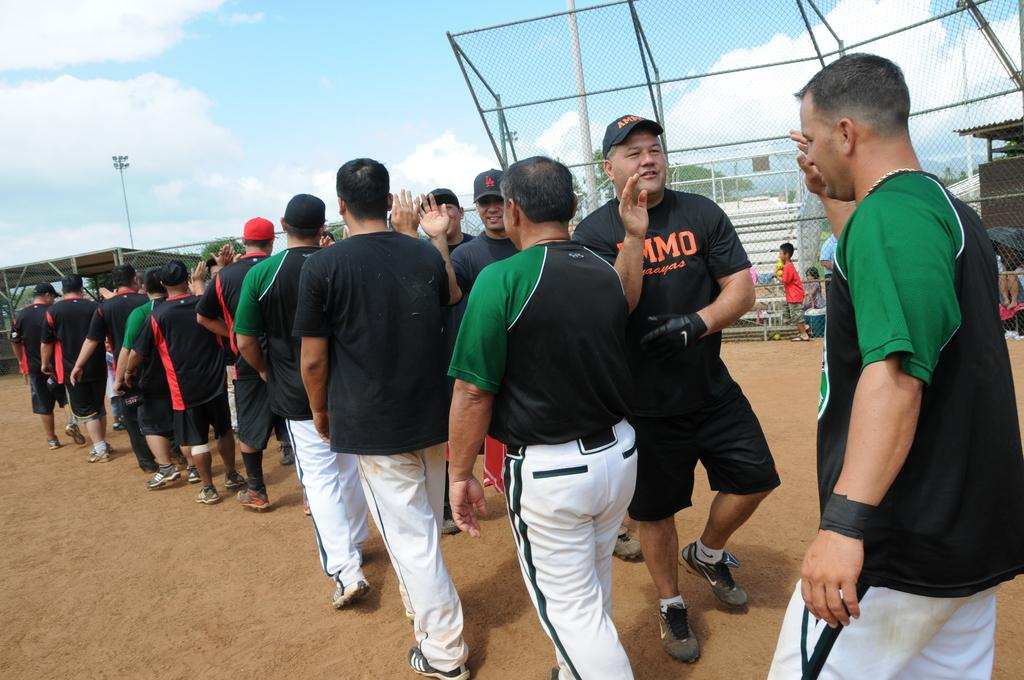<image>
Provide a brief description of the given image. A man in a shirt that says Ammo walks down the line at the end of a baseball game. 